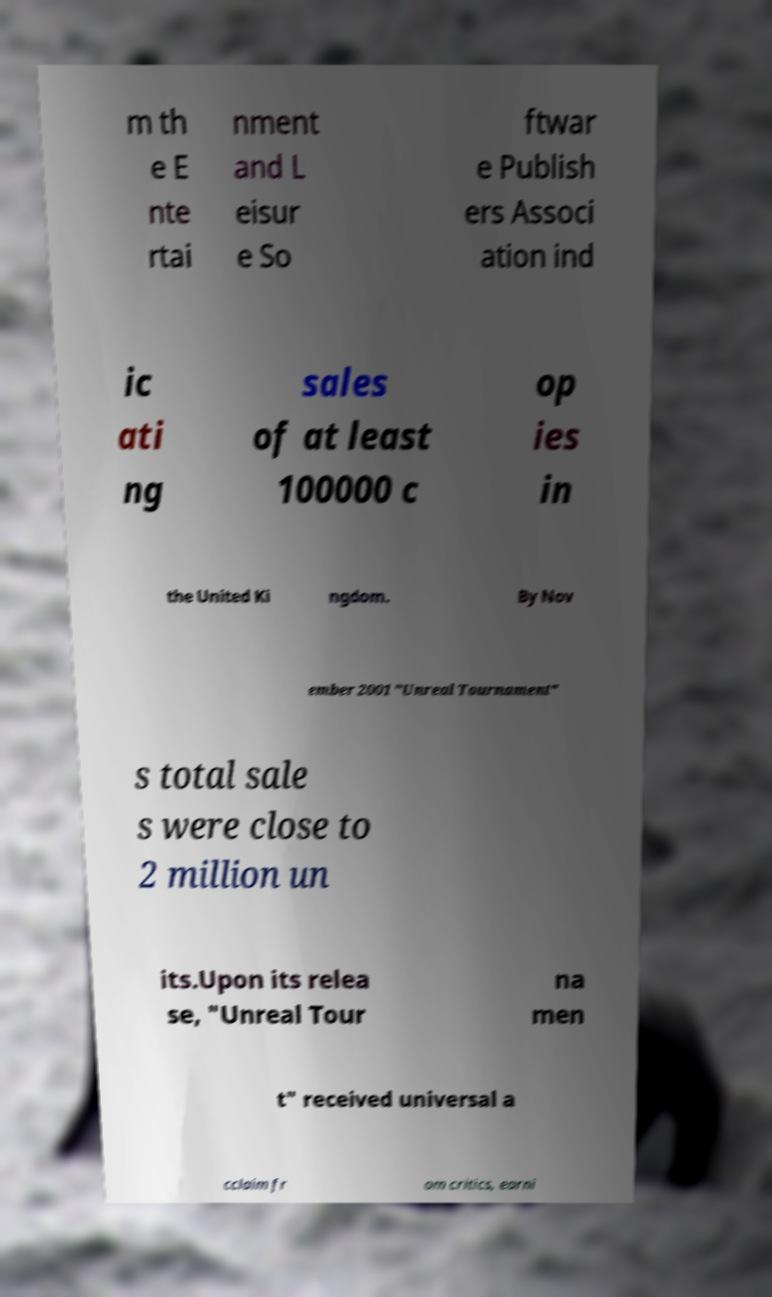Please identify and transcribe the text found in this image. m th e E nte rtai nment and L eisur e So ftwar e Publish ers Associ ation ind ic ati ng sales of at least 100000 c op ies in the United Ki ngdom. By Nov ember 2001 "Unreal Tournament" s total sale s were close to 2 million un its.Upon its relea se, "Unreal Tour na men t" received universal a cclaim fr om critics, earni 